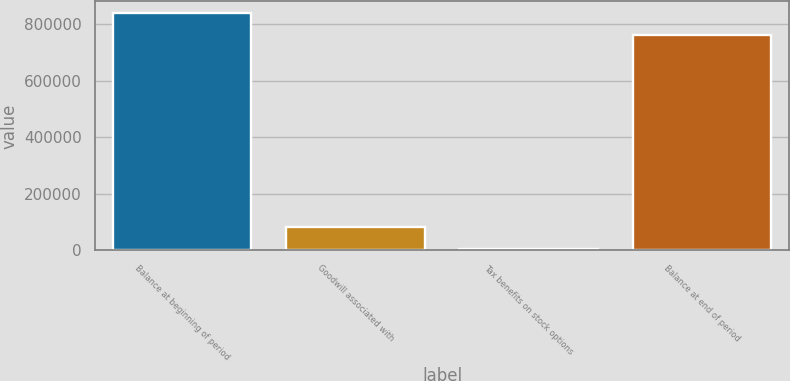Convert chart to OTSL. <chart><loc_0><loc_0><loc_500><loc_500><bar_chart><fcel>Balance at beginning of period<fcel>Goodwill associated with<fcel>Tax benefits on stock options<fcel>Balance at end of period<nl><fcel>838055<fcel>83261.7<fcel>5703<fcel>760496<nl></chart> 